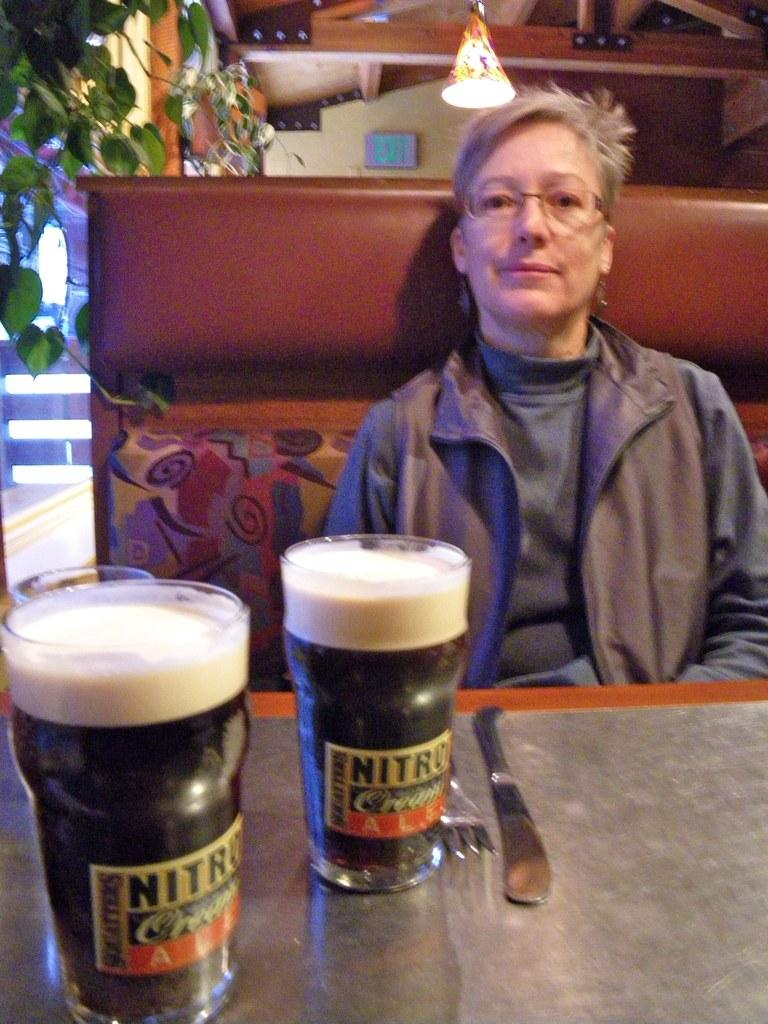<image>
Render a clear and concise summary of the photo. A woman sits at a booth with two full Nitro Ales at the table. 